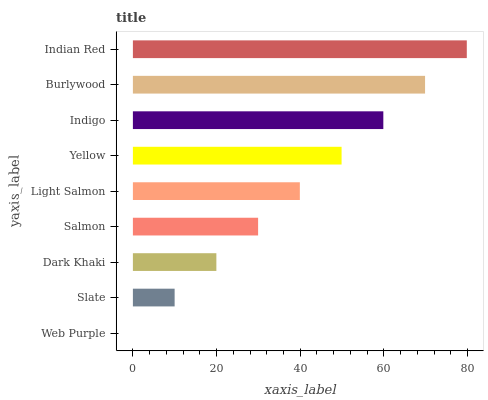Is Web Purple the minimum?
Answer yes or no. Yes. Is Indian Red the maximum?
Answer yes or no. Yes. Is Slate the minimum?
Answer yes or no. No. Is Slate the maximum?
Answer yes or no. No. Is Slate greater than Web Purple?
Answer yes or no. Yes. Is Web Purple less than Slate?
Answer yes or no. Yes. Is Web Purple greater than Slate?
Answer yes or no. No. Is Slate less than Web Purple?
Answer yes or no. No. Is Light Salmon the high median?
Answer yes or no. Yes. Is Light Salmon the low median?
Answer yes or no. Yes. Is Indigo the high median?
Answer yes or no. No. Is Yellow the low median?
Answer yes or no. No. 